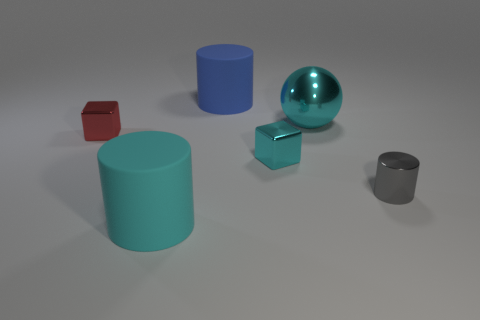Add 2 cyan cylinders. How many objects exist? 8 Subtract all blocks. How many objects are left? 4 Subtract all blue cylinders. Subtract all large gray matte objects. How many objects are left? 5 Add 5 big cyan things. How many big cyan things are left? 7 Add 5 brown shiny objects. How many brown shiny objects exist? 5 Subtract 0 yellow cylinders. How many objects are left? 6 